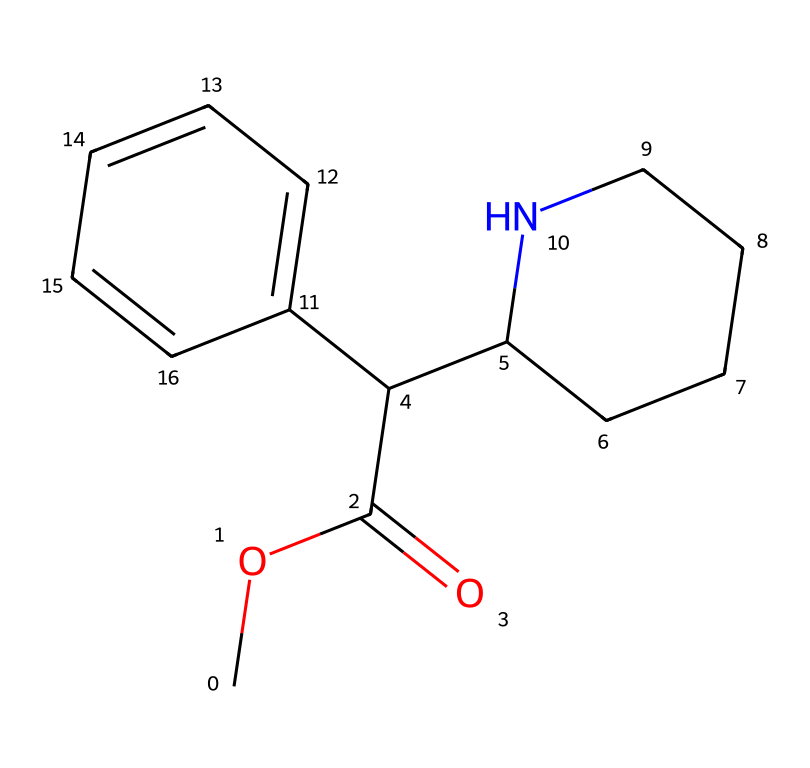What is the molecular formula of this compound? To determine the molecular formula, we need to count the number of each type of atom in the SMILES representation. Analyzing the SMILES shows there are 16 carbon (C), 21 hydrogen (H), 1 nitrogen (N), and 2 oxygen (O) atoms. Hence, the molecular formula is C16H21N2O2.
Answer: C16H21N2O2 How many carbon atoms are present in this chemical structure? From the SMILES, we can see that the carbon atoms are represented throughout the structure. By examining the segments such as the acetyl group (COC(=O)) and the bicyclic structure, we count a total of 16 carbon atoms.
Answer: 16 What functional groups are present in this compound? The prominent functional groups identifiable in the structure are the ester (–COC(=O)–) and the amine (the ring with nitrogen). These groups contribute to the implications of the compound's properties and reactivity.
Answer: ester, amine Does this chemical contain any phosphorus atoms? Analyzing the given SMILES, we identify that there are no phosphorus (P) atoms present in the structure. As we observe the components of the molecule, we find no indication of phosphorus.
Answer: no What type of bond connects the nitrogen atom to the carbon chain? In the chemical structure, the nitrogen atom is part of a ring structure connected to a carbon atom. This bond is a single covalent bond (σ bond), as depicted in the representation.
Answer: single bond How many rings are present in this chemical structure? Observing the structure in the SMILES, we can discern that there are two distinct ring structures: one involving the nitrogen atom and a carbon chain, while the other is a phenyl ring. Counting these gives us a total of two rings.
Answer: 2 